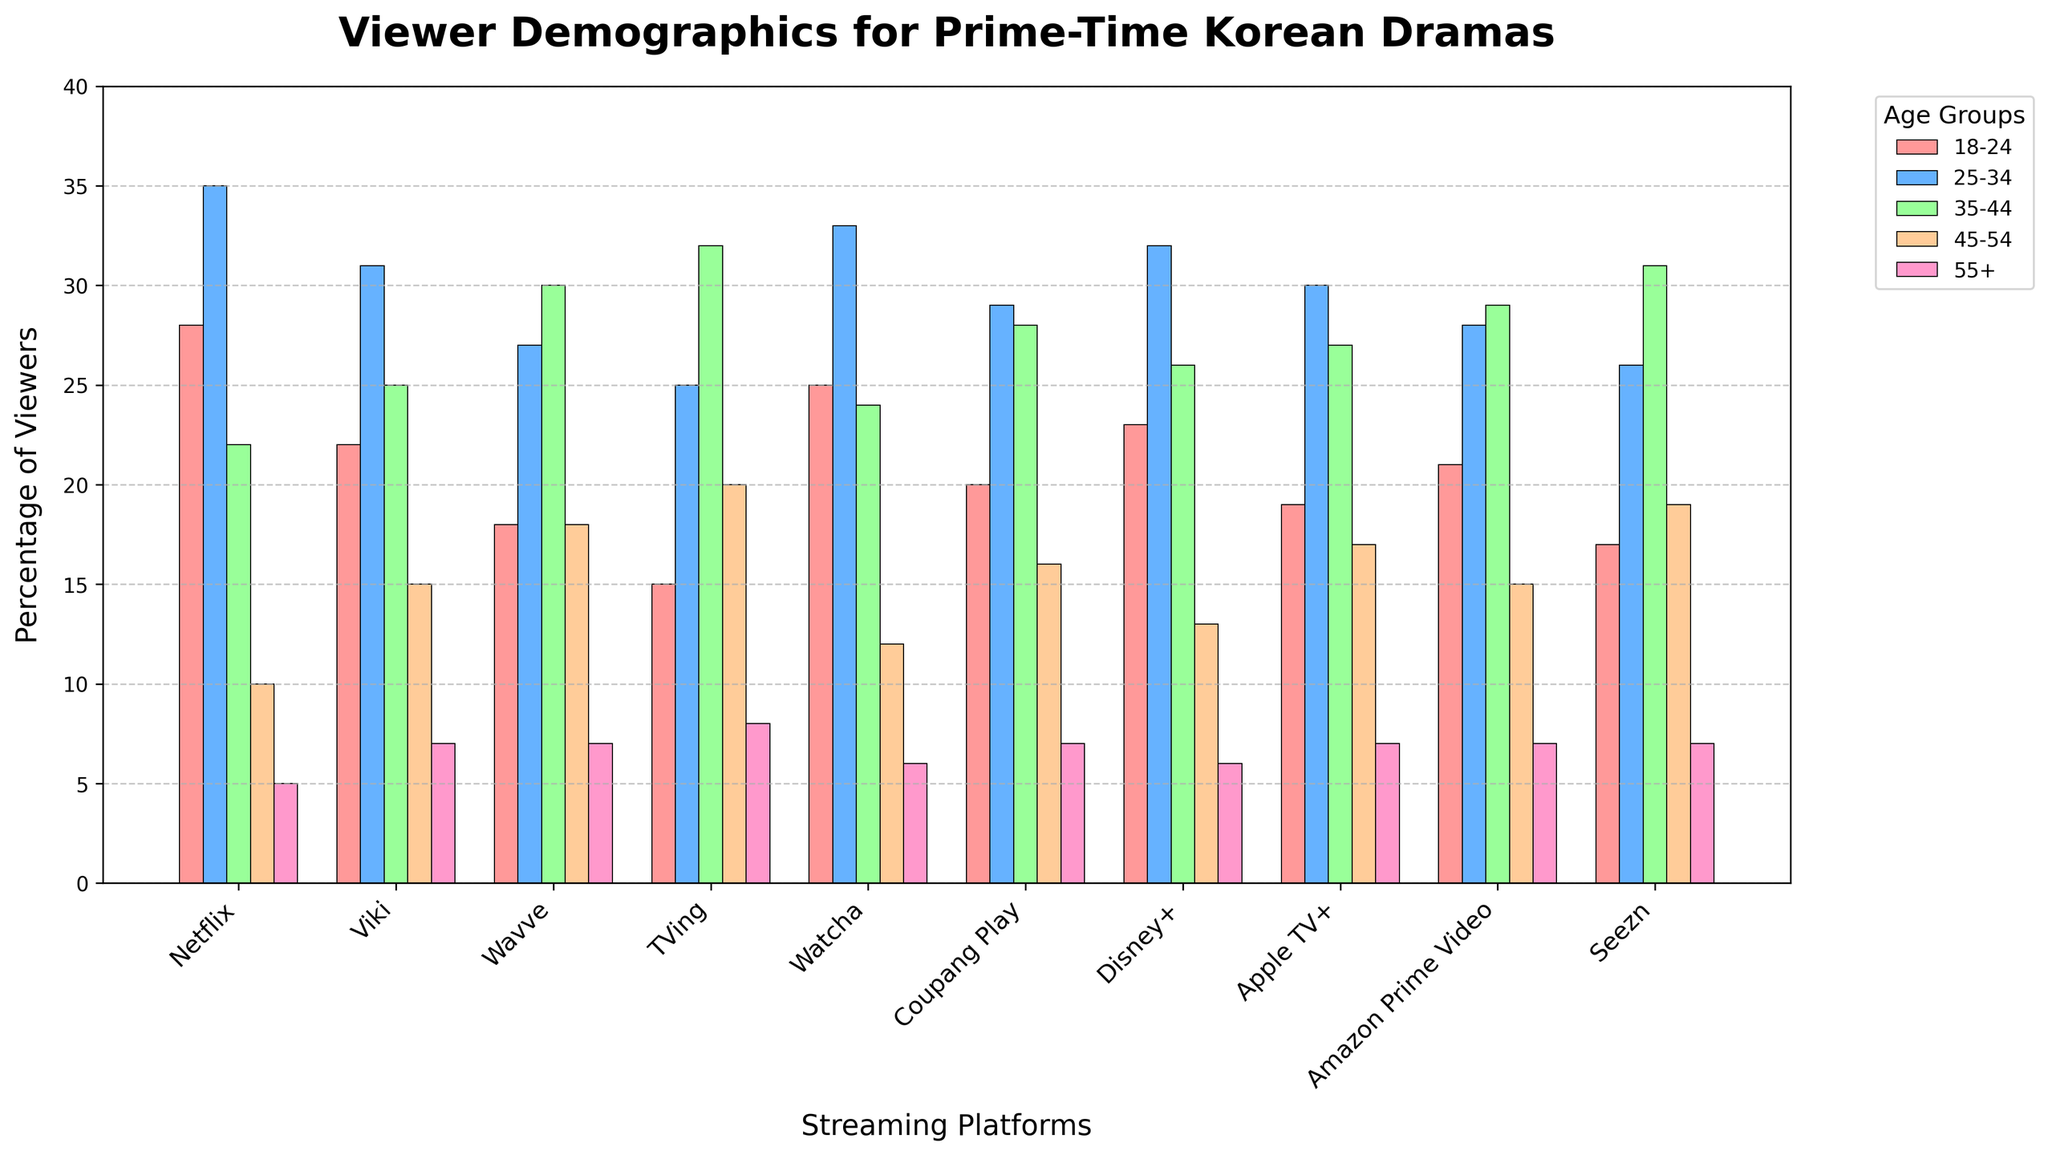Which streaming platform has the highest percentage of viewers in the 18-24 age group? Look for the platform with the highest bar in the 18-24 age group's color. Netflix's bar is the highest at 28%.
Answer: Netflix Which age group has the smallest representation across all platforms? Identify the color representing each age group and compare the heights of the bars across all platforms. The 55+ age group has the smallest overall representation with the percentage not exceeding 8% on any platform.
Answer: 55+ What is the total percentage of viewers aged 25-34 on Netflix and Viki combined? Look at the bars for both Netflix and Viki in the 25-34 age group and add the percentages: 35 (Netflix) + 31 (Viki) = 66.
Answer: 66% Which two platforms have the most similar percentages of 35-44 aged viewers? Compare the 35-44 percentage bars for each platform to identify which two have similar heights. Coupang Play and Apple TV+ both have 28%.
Answer: Coupang Play and Apple TV+ How do the percentages of the 45-54 age group on Wavve and TVing compare? Compare the height of the bars for the 45-54 age group on Wavve and TVing. Wavve has 18% and TVing has 20%. TVing has a slightly higher percentage.
Answer: TVing Which platform has a higher percentage of viewers aged 18-24, Netflix or Watcha? Compare the 18-24 age group bars for Netflix and Watcha. Netflix has 28%, while Watcha has 25%.
Answer: Netflix What is the difference in the percentage of viewers aged 55+ on TVing and Disney+? Subtract the percentage for Disney+ from that of TVing: 8 (TVing) - 6 (Disney+) = 2.
Answer: 2 Across all platforms, which age group consistently covers the highest percentage? Observe the bars' heights for each age group across all platforms to find the highest: The 25-34 age group consistently has the highest bars.
Answer: 25-34 How does the viewer distribution of Amazon Prime Video in the 35-44 age group compare to Netflix? Compare the height of the bars for the 35-44 age group on Amazon Prime Video and Netflix. Amazon Prime Video has 29%, while Netflix has 22%. Amazon Prime Video's percentage is higher.
Answer: Amazon Prime Video What is the average percentage of viewers aged 45+ across all streaming platforms? For each platform, sum the percentages of the 45-54 and 55+ age groups, and divide by the number of platforms: (10+5 + 15+7 + 18+7 + 20+8 + 12+6 + 16+7 + 13+6 + 17+7 + 15+7 + 19+7) / 10 = 16.9.
Answer: 16.9% 